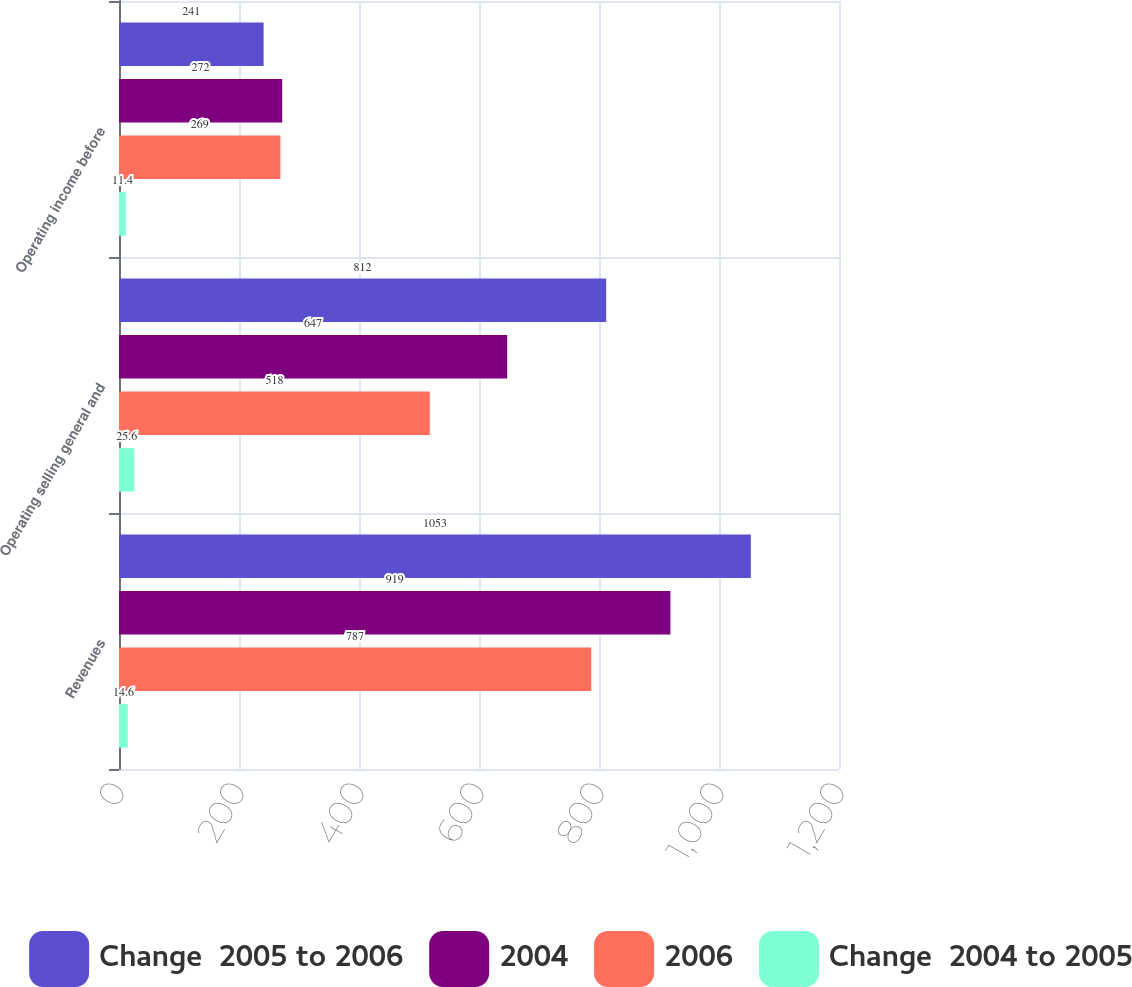<chart> <loc_0><loc_0><loc_500><loc_500><stacked_bar_chart><ecel><fcel>Revenues<fcel>Operating selling general and<fcel>Operating income before<nl><fcel>Change  2005 to 2006<fcel>1053<fcel>812<fcel>241<nl><fcel>2004<fcel>919<fcel>647<fcel>272<nl><fcel>2006<fcel>787<fcel>518<fcel>269<nl><fcel>Change  2004 to 2005<fcel>14.6<fcel>25.6<fcel>11.4<nl></chart> 